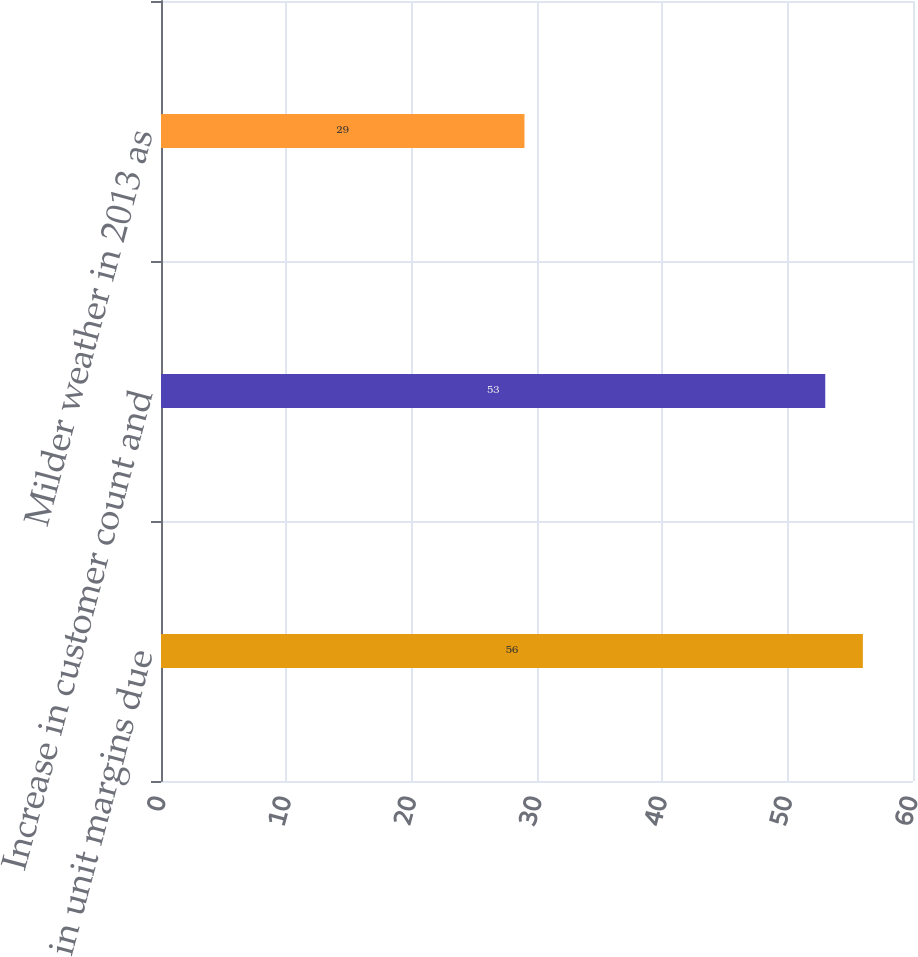Convert chart to OTSL. <chart><loc_0><loc_0><loc_500><loc_500><bar_chart><fcel>Decrease in unit margins due<fcel>Increase in customer count and<fcel>Milder weather in 2013 as<nl><fcel>56<fcel>53<fcel>29<nl></chart> 